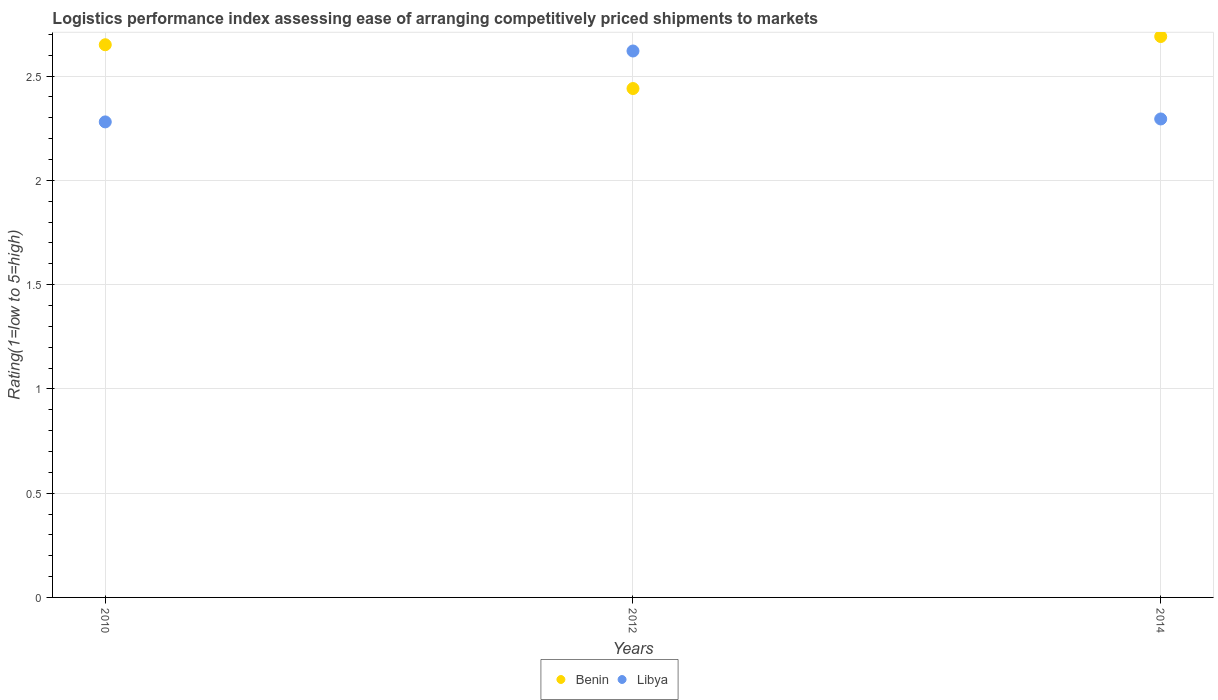Is the number of dotlines equal to the number of legend labels?
Your response must be concise. Yes. What is the Logistic performance index in Libya in 2010?
Your answer should be compact. 2.28. Across all years, what is the maximum Logistic performance index in Libya?
Offer a terse response. 2.62. Across all years, what is the minimum Logistic performance index in Benin?
Ensure brevity in your answer.  2.44. In which year was the Logistic performance index in Libya maximum?
Provide a short and direct response. 2012. In which year was the Logistic performance index in Benin minimum?
Offer a terse response. 2012. What is the total Logistic performance index in Libya in the graph?
Keep it short and to the point. 7.19. What is the difference between the Logistic performance index in Benin in 2010 and that in 2012?
Your response must be concise. 0.21. What is the difference between the Logistic performance index in Libya in 2014 and the Logistic performance index in Benin in 2010?
Offer a terse response. -0.36. What is the average Logistic performance index in Benin per year?
Provide a succinct answer. 2.59. In the year 2010, what is the difference between the Logistic performance index in Benin and Logistic performance index in Libya?
Offer a terse response. 0.37. In how many years, is the Logistic performance index in Libya greater than 1.4?
Provide a short and direct response. 3. What is the ratio of the Logistic performance index in Libya in 2010 to that in 2014?
Ensure brevity in your answer.  0.99. Is the Logistic performance index in Benin in 2010 less than that in 2012?
Offer a terse response. No. What is the difference between the highest and the second highest Logistic performance index in Benin?
Provide a succinct answer. 0.04. What is the difference between the highest and the lowest Logistic performance index in Libya?
Ensure brevity in your answer.  0.34. Is the sum of the Logistic performance index in Benin in 2012 and 2014 greater than the maximum Logistic performance index in Libya across all years?
Offer a very short reply. Yes. Is the Logistic performance index in Benin strictly greater than the Logistic performance index in Libya over the years?
Your answer should be compact. No. How many dotlines are there?
Keep it short and to the point. 2. How many years are there in the graph?
Give a very brief answer. 3. What is the difference between two consecutive major ticks on the Y-axis?
Make the answer very short. 0.5. Are the values on the major ticks of Y-axis written in scientific E-notation?
Keep it short and to the point. No. Does the graph contain any zero values?
Offer a very short reply. No. Does the graph contain grids?
Keep it short and to the point. Yes. Where does the legend appear in the graph?
Provide a succinct answer. Bottom center. How many legend labels are there?
Keep it short and to the point. 2. How are the legend labels stacked?
Your answer should be compact. Horizontal. What is the title of the graph?
Your response must be concise. Logistics performance index assessing ease of arranging competitively priced shipments to markets. Does "Paraguay" appear as one of the legend labels in the graph?
Offer a very short reply. No. What is the label or title of the X-axis?
Your answer should be compact. Years. What is the label or title of the Y-axis?
Ensure brevity in your answer.  Rating(1=low to 5=high). What is the Rating(1=low to 5=high) of Benin in 2010?
Give a very brief answer. 2.65. What is the Rating(1=low to 5=high) of Libya in 2010?
Offer a very short reply. 2.28. What is the Rating(1=low to 5=high) in Benin in 2012?
Give a very brief answer. 2.44. What is the Rating(1=low to 5=high) of Libya in 2012?
Give a very brief answer. 2.62. What is the Rating(1=low to 5=high) of Benin in 2014?
Your response must be concise. 2.69. What is the Rating(1=low to 5=high) of Libya in 2014?
Give a very brief answer. 2.29. Across all years, what is the maximum Rating(1=low to 5=high) of Benin?
Offer a very short reply. 2.69. Across all years, what is the maximum Rating(1=low to 5=high) in Libya?
Give a very brief answer. 2.62. Across all years, what is the minimum Rating(1=low to 5=high) in Benin?
Provide a short and direct response. 2.44. Across all years, what is the minimum Rating(1=low to 5=high) in Libya?
Your answer should be compact. 2.28. What is the total Rating(1=low to 5=high) in Benin in the graph?
Your answer should be very brief. 7.78. What is the total Rating(1=low to 5=high) in Libya in the graph?
Your answer should be very brief. 7.19. What is the difference between the Rating(1=low to 5=high) of Benin in 2010 and that in 2012?
Give a very brief answer. 0.21. What is the difference between the Rating(1=low to 5=high) of Libya in 2010 and that in 2012?
Keep it short and to the point. -0.34. What is the difference between the Rating(1=low to 5=high) in Benin in 2010 and that in 2014?
Provide a succinct answer. -0.04. What is the difference between the Rating(1=low to 5=high) in Libya in 2010 and that in 2014?
Offer a terse response. -0.01. What is the difference between the Rating(1=low to 5=high) of Benin in 2012 and that in 2014?
Ensure brevity in your answer.  -0.25. What is the difference between the Rating(1=low to 5=high) of Libya in 2012 and that in 2014?
Provide a short and direct response. 0.33. What is the difference between the Rating(1=low to 5=high) in Benin in 2010 and the Rating(1=low to 5=high) in Libya in 2012?
Provide a short and direct response. 0.03. What is the difference between the Rating(1=low to 5=high) in Benin in 2010 and the Rating(1=low to 5=high) in Libya in 2014?
Your answer should be very brief. 0.36. What is the difference between the Rating(1=low to 5=high) of Benin in 2012 and the Rating(1=low to 5=high) of Libya in 2014?
Offer a very short reply. 0.15. What is the average Rating(1=low to 5=high) in Benin per year?
Make the answer very short. 2.59. What is the average Rating(1=low to 5=high) of Libya per year?
Ensure brevity in your answer.  2.4. In the year 2010, what is the difference between the Rating(1=low to 5=high) in Benin and Rating(1=low to 5=high) in Libya?
Offer a very short reply. 0.37. In the year 2012, what is the difference between the Rating(1=low to 5=high) in Benin and Rating(1=low to 5=high) in Libya?
Your answer should be compact. -0.18. In the year 2014, what is the difference between the Rating(1=low to 5=high) in Benin and Rating(1=low to 5=high) in Libya?
Keep it short and to the point. 0.4. What is the ratio of the Rating(1=low to 5=high) of Benin in 2010 to that in 2012?
Your answer should be compact. 1.09. What is the ratio of the Rating(1=low to 5=high) of Libya in 2010 to that in 2012?
Ensure brevity in your answer.  0.87. What is the ratio of the Rating(1=low to 5=high) of Benin in 2010 to that in 2014?
Provide a succinct answer. 0.99. What is the ratio of the Rating(1=low to 5=high) in Benin in 2012 to that in 2014?
Provide a short and direct response. 0.91. What is the ratio of the Rating(1=low to 5=high) of Libya in 2012 to that in 2014?
Your answer should be very brief. 1.14. What is the difference between the highest and the second highest Rating(1=low to 5=high) in Benin?
Offer a very short reply. 0.04. What is the difference between the highest and the second highest Rating(1=low to 5=high) of Libya?
Your answer should be compact. 0.33. What is the difference between the highest and the lowest Rating(1=low to 5=high) in Benin?
Make the answer very short. 0.25. What is the difference between the highest and the lowest Rating(1=low to 5=high) in Libya?
Keep it short and to the point. 0.34. 